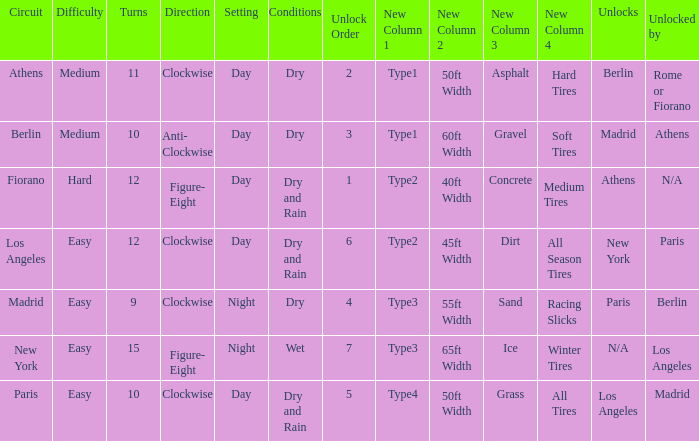How many instances is paris the unlock? 1.0. 